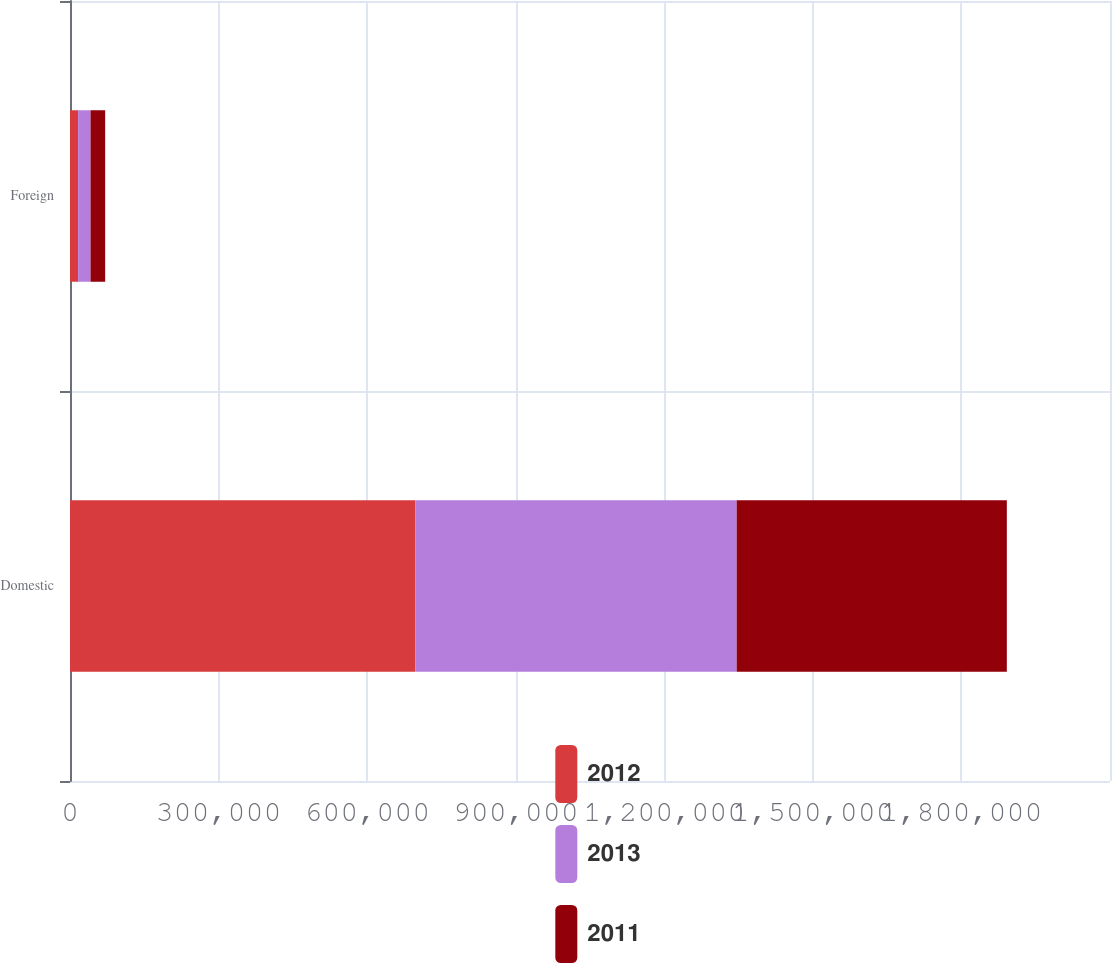<chart> <loc_0><loc_0><loc_500><loc_500><stacked_bar_chart><ecel><fcel>Domestic<fcel>Foreign<nl><fcel>2012<fcel>697062<fcel>16406<nl><fcel>2013<fcel>649098<fcel>25057<nl><fcel>2011<fcel>545527<fcel>29554<nl></chart> 